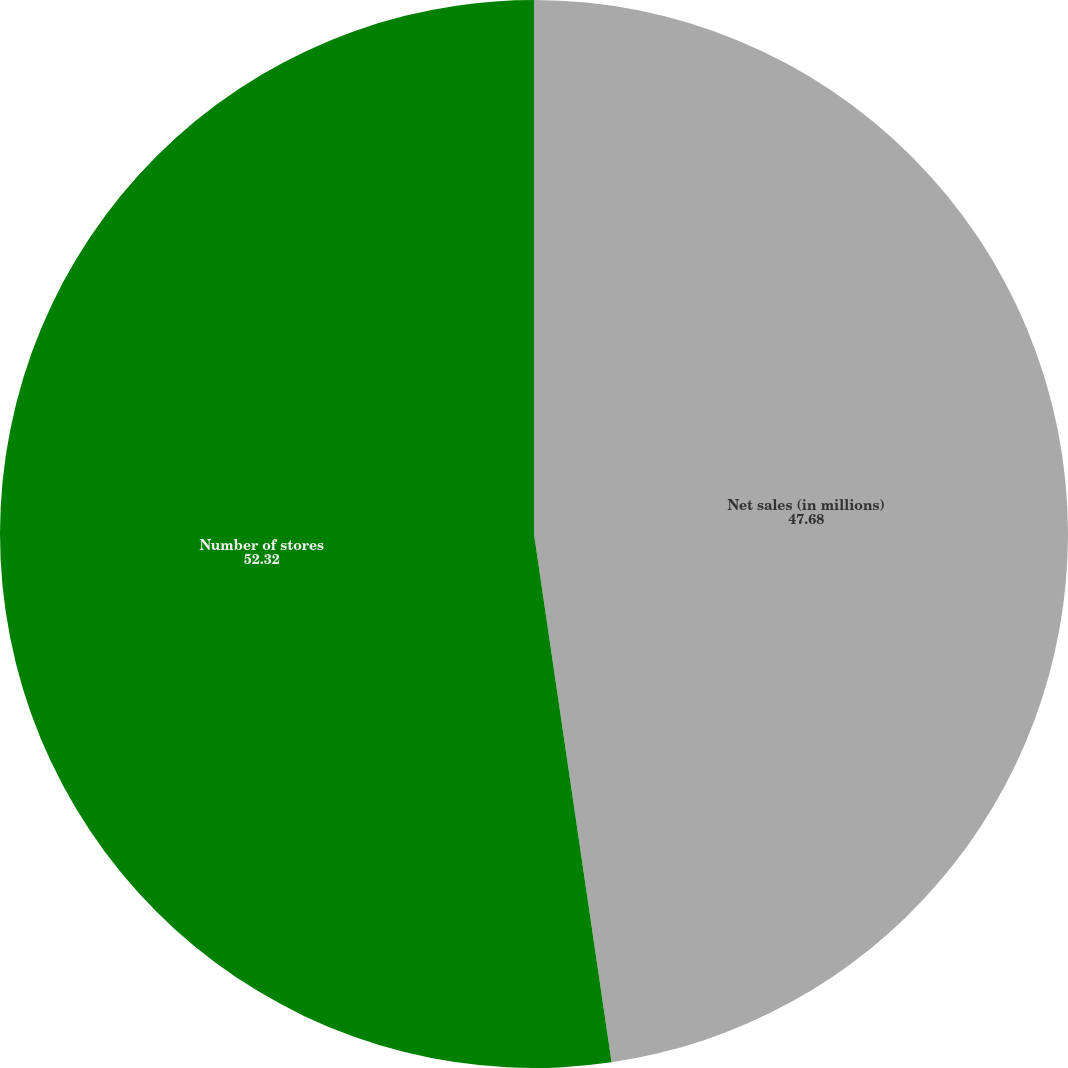<chart> <loc_0><loc_0><loc_500><loc_500><pie_chart><fcel>Net sales (in millions)<fcel>Number of stores<nl><fcel>47.68%<fcel>52.32%<nl></chart> 